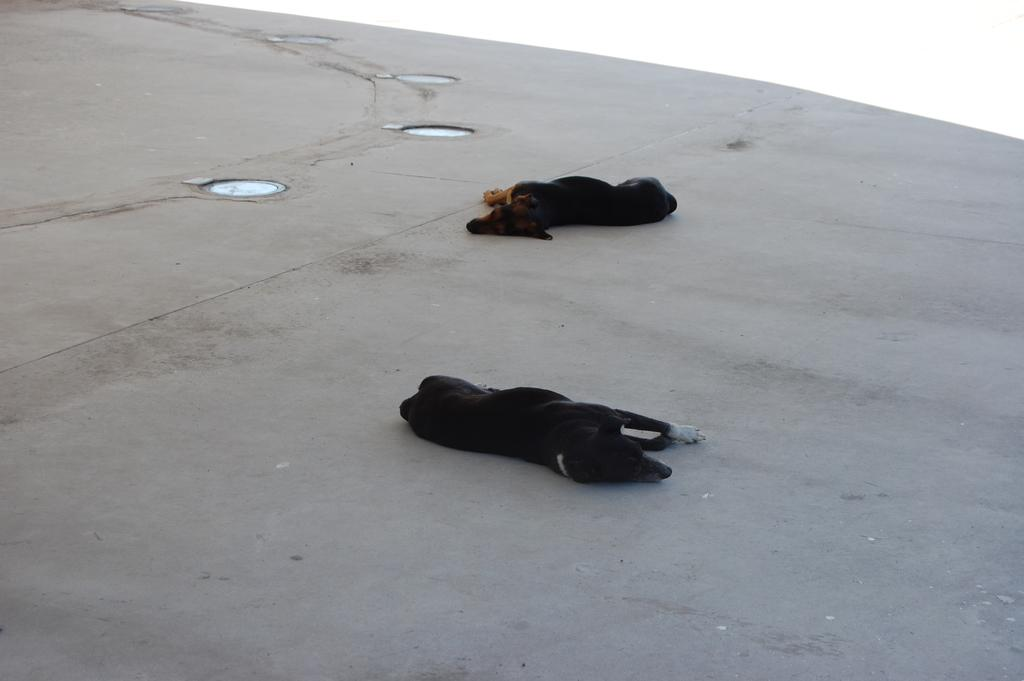How many dogs are in the image? There are two black color dogs in the image. What are the dogs doing in the image? The dogs are lying on the ground. What else can be seen on the ground in the image? There are other objects on the ground. What is the color of the background in the image? The background of the image is white in color. Can you tell me where the fireman is standing in the image? There is no fireman present in the image; it only features two black color dogs lying on the ground. 